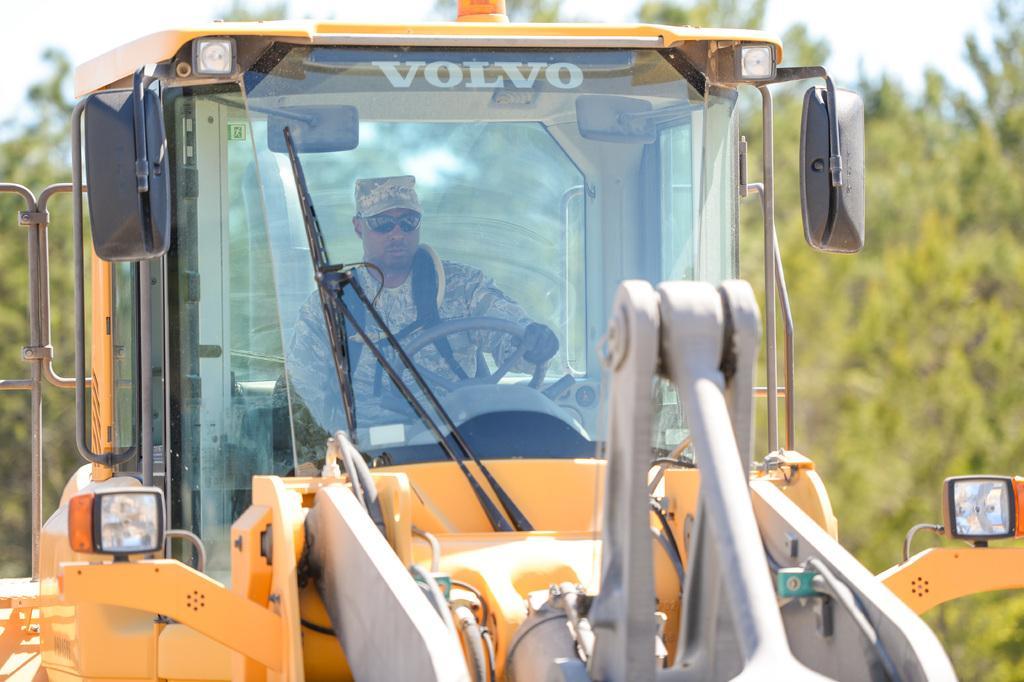Could you give a brief overview of what you see in this image? In this picture we can able to see a vehicle it is driven by a man. The man is holding a steering and he is driving. Background of this vehicle there are group of trees. The sky is in white color. This vehicle is in orange color. The man wore military dress and military cap. 